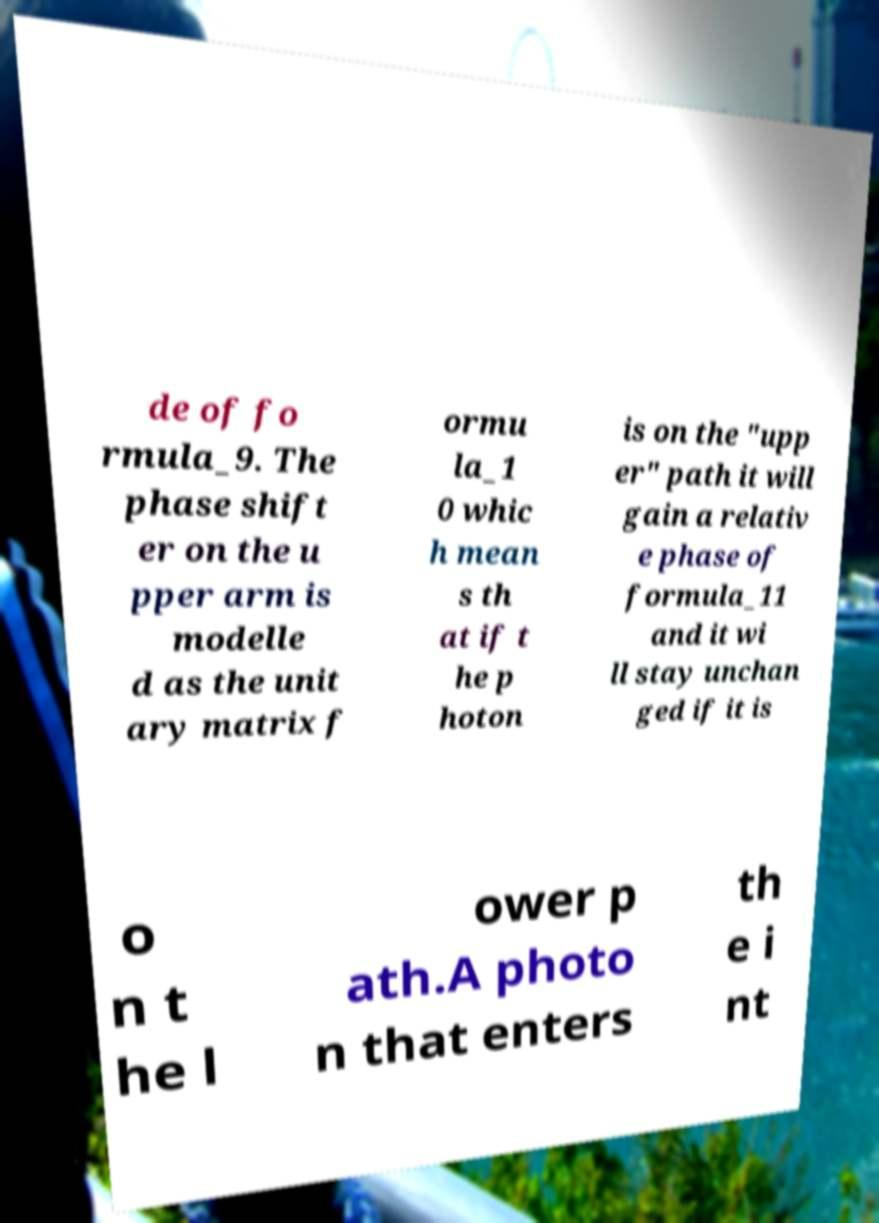I need the written content from this picture converted into text. Can you do that? de of fo rmula_9. The phase shift er on the u pper arm is modelle d as the unit ary matrix f ormu la_1 0 whic h mean s th at if t he p hoton is on the "upp er" path it will gain a relativ e phase of formula_11 and it wi ll stay unchan ged if it is o n t he l ower p ath.A photo n that enters th e i nt 